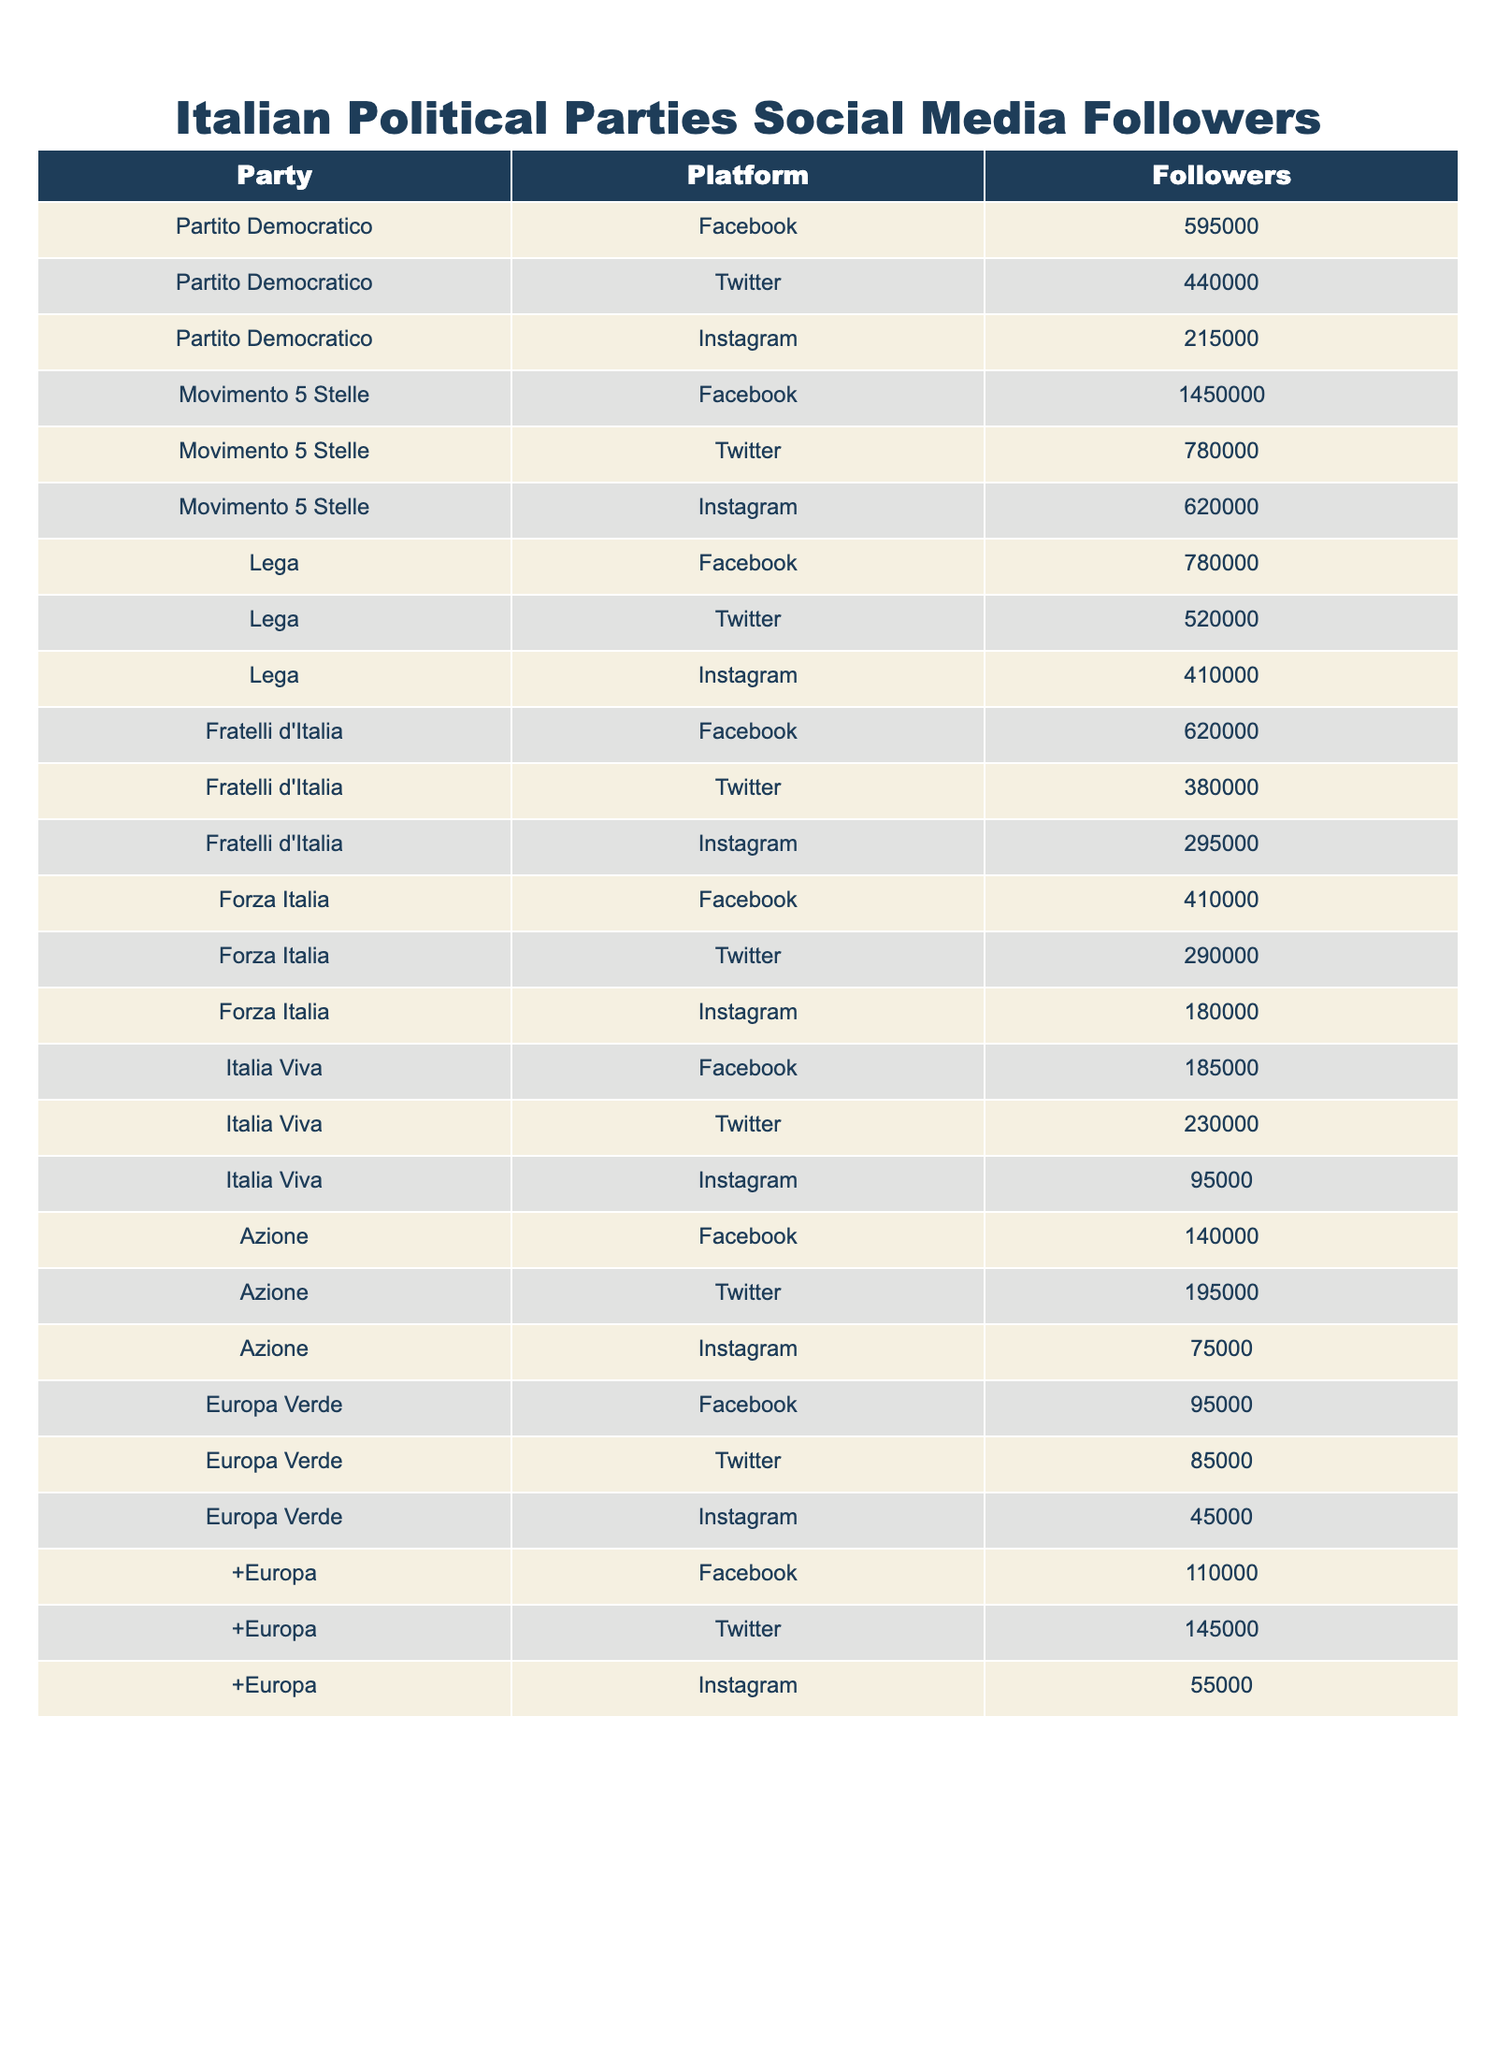What's the total number of followers for the Movimento 5 Stelle party across all platforms? To find the total, we need to sum up the followers on Facebook (1,450,000), Twitter (780,000), and Instagram (620,000). So, the total is 1,450,000 + 780,000 + 620,000 = 2,850,000.
Answer: 2,850,000 Which party has the highest number of followers on Instagram? Looking at the Instagram followers, Movimento 5 Stelle has 620,000 followers, which is higher compared to other parties.
Answer: Movimento 5 Stelle What is the difference in followers between the Lega and Italia Viva on Twitter? Lega has 520,000 followers and Italia Viva has 230,000 followers. The difference is 520,000 - 230,000 = 290,000.
Answer: 290,000 Does Forza Italia have more followers on Facebook than Fratelli d'Italia? Forza Italia has 410,000 followers on Facebook while Fratelli d'Italia has 620,000 followers. Since 410,000 < 620,000, the statement is false.
Answer: No What is the average number of Instagram followers among the parties listed? We add up all the Instagram followers (215,000 + 620,000 + 410,000 + 295,000 + 180,000 + 95,000 + 75,000 + 45,000 + 55,000) = 1,990,000. There are 9 parties, so the average is 1,990,000 / 9 ≈ 221,111.11.
Answer: Approximately 221,111 Which party has the least number of followers on Facebook? We compare the Facebook followers: Partito Democratico (595,000), Movimento 5 Stelle (1,450,000), Lega (780,000), Fratelli d'Italia (620,000), Forza Italia (410,000), Italia Viva (185,000), Azione (140,000), Europa Verde (95,000), +Europa (110,000). The least is Europa Verde with 95,000.
Answer: Europa Verde 